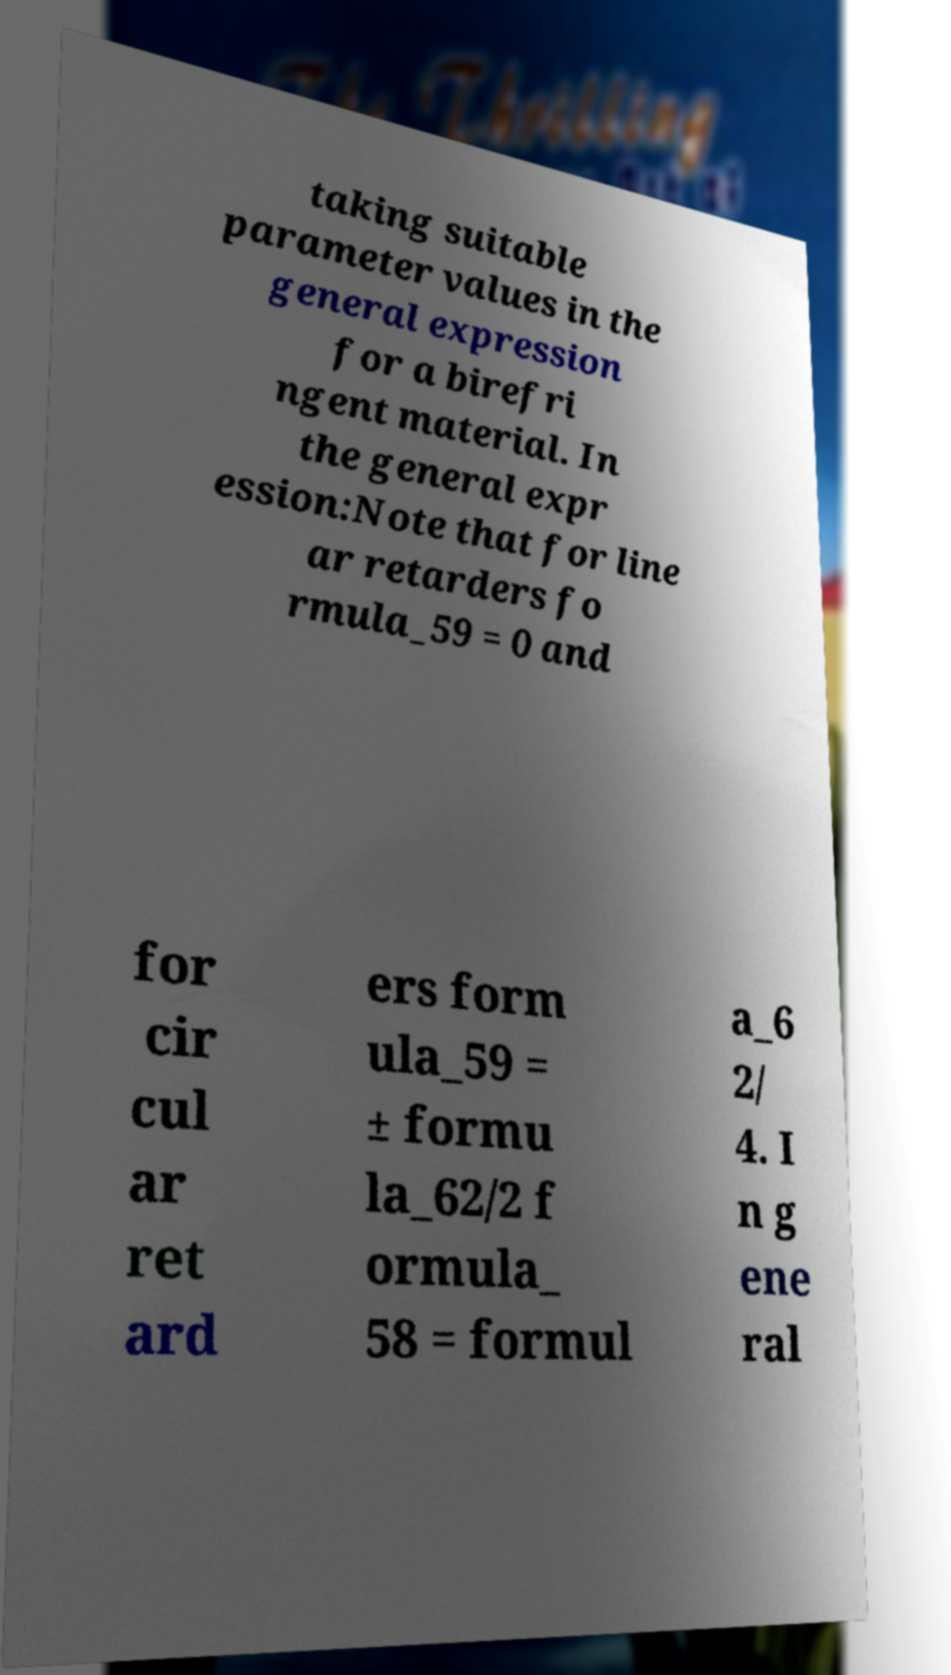Could you extract and type out the text from this image? taking suitable parameter values in the general expression for a birefri ngent material. In the general expr ession:Note that for line ar retarders fo rmula_59 = 0 and for cir cul ar ret ard ers form ula_59 = ± formu la_62/2 f ormula_ 58 = formul a_6 2/ 4. I n g ene ral 